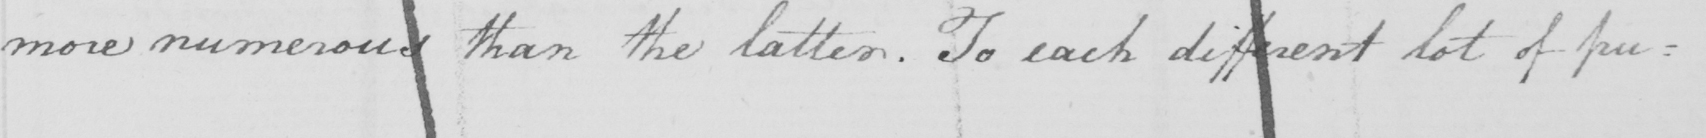Can you tell me what this handwritten text says? more numerous than the latter . To each different lot of pu= 